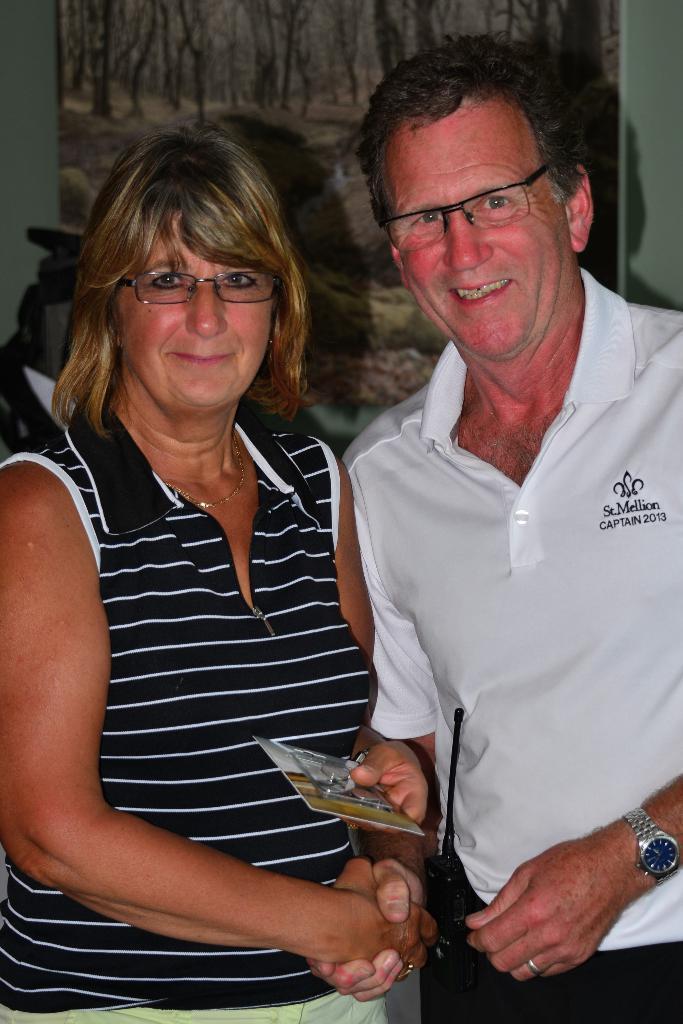Please provide a concise description of this image. In the picture we can see a man and a woman standing together and smiling, the woman is wearing a black top with white color lines on it and man is wearing a white T-shirt and woman is holding something in the hand and behind them we can see a wall with a poster of a scenery. 